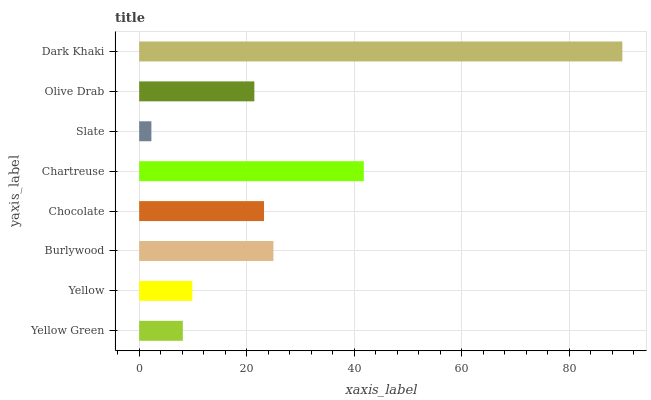Is Slate the minimum?
Answer yes or no. Yes. Is Dark Khaki the maximum?
Answer yes or no. Yes. Is Yellow the minimum?
Answer yes or no. No. Is Yellow the maximum?
Answer yes or no. No. Is Yellow greater than Yellow Green?
Answer yes or no. Yes. Is Yellow Green less than Yellow?
Answer yes or no. Yes. Is Yellow Green greater than Yellow?
Answer yes or no. No. Is Yellow less than Yellow Green?
Answer yes or no. No. Is Chocolate the high median?
Answer yes or no. Yes. Is Olive Drab the low median?
Answer yes or no. Yes. Is Yellow the high median?
Answer yes or no. No. Is Yellow the low median?
Answer yes or no. No. 